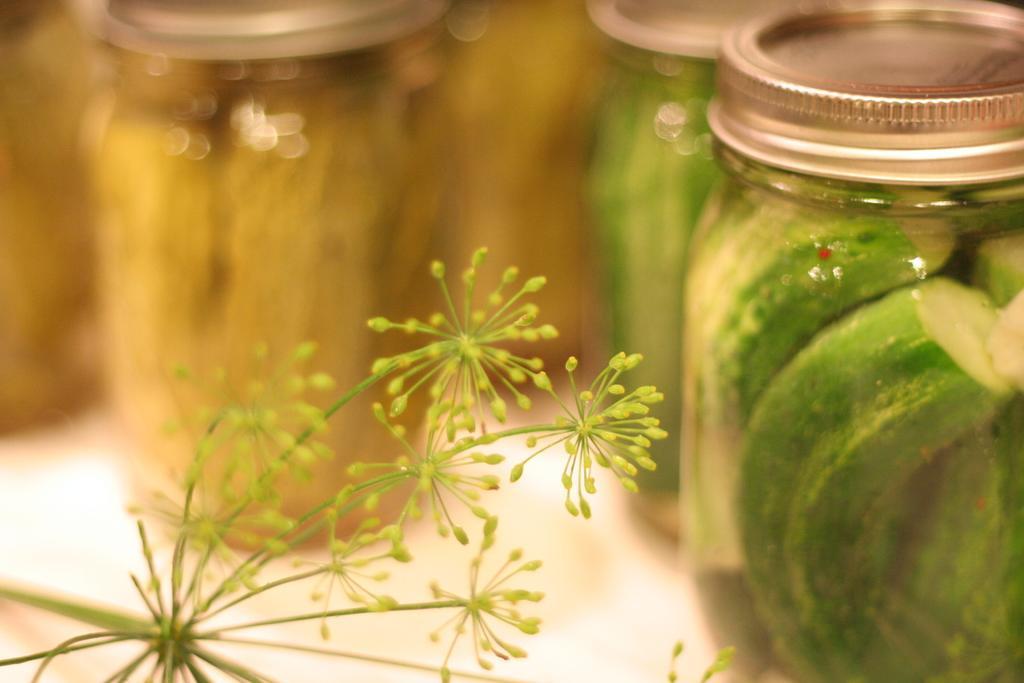Please provide a concise description of this image. In the image there are dandelions on the left side and on the right side there are jars with pickles in them. 